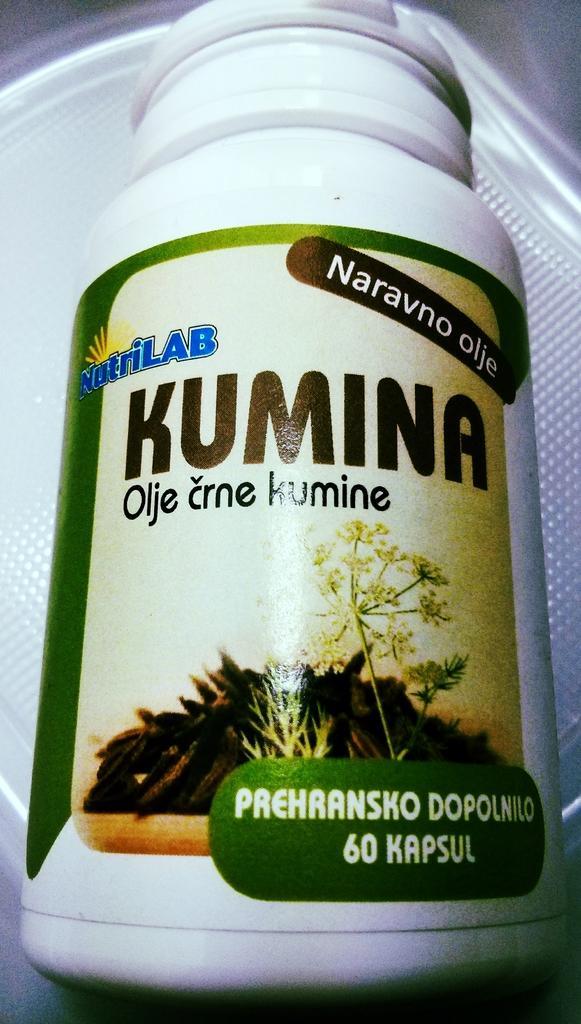Please provide a concise description of this image. In this image we can see a white color bottle with some text on it, on the white color surface. 